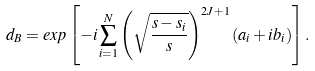Convert formula to latex. <formula><loc_0><loc_0><loc_500><loc_500>d _ { B } = e x p \left [ - i \sum _ { i = 1 } ^ { N } \left ( \sqrt { \frac { s - s _ { i } } { s } } \right ) ^ { 2 J + 1 } ( a _ { i } + i b _ { i } ) \right ] .</formula> 